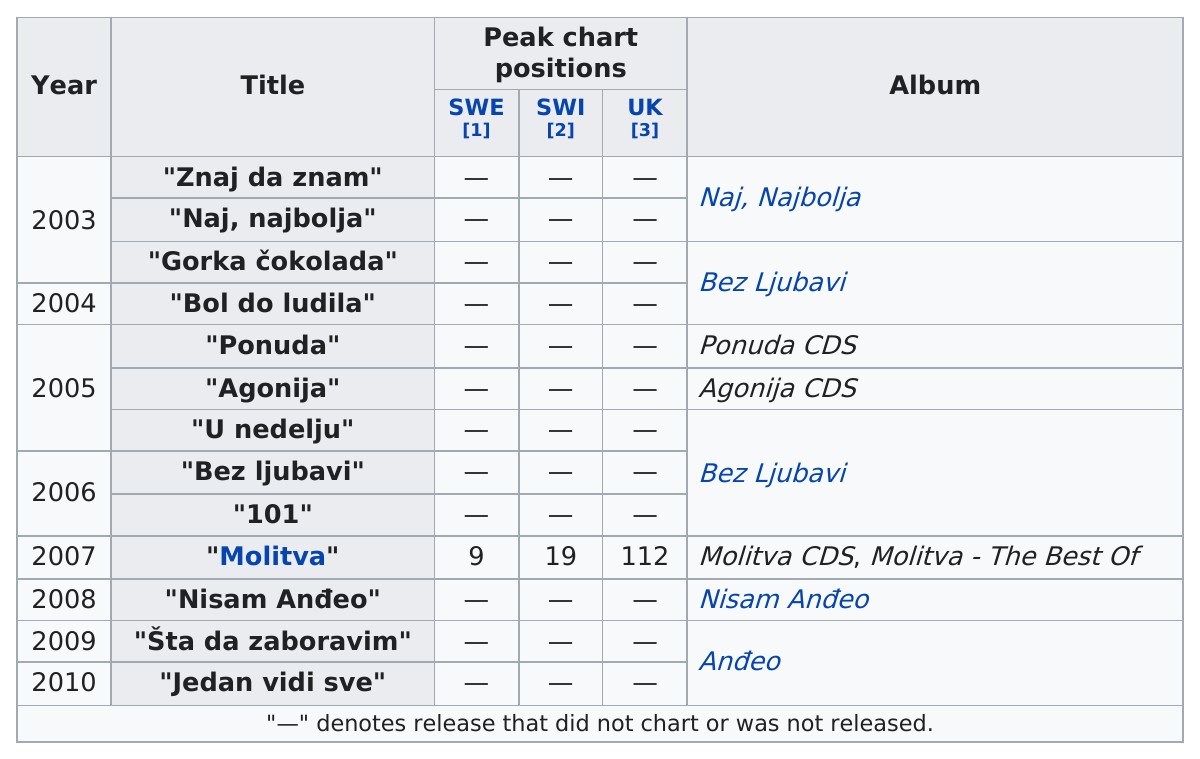Mention a couple of crucial points in this snapshot. Moltiva placed 10 positions above in the swe vs swi competition. The first single that was released by her was "Znaj da znam. The band was around for 8 years. The singer did not have a single on a chart for 4 consecutive years. The name of the first album produced by this singer is "Naj, Najbolja Pjesma Moje Žene. 